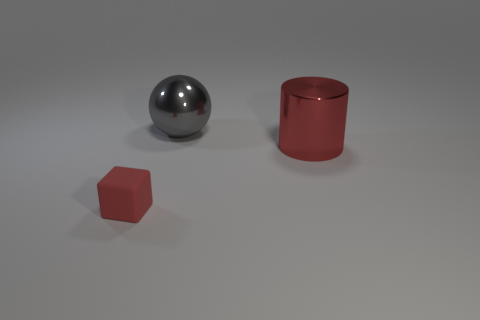Add 3 yellow rubber cubes. How many objects exist? 6 Subtract 0 blue balls. How many objects are left? 3 Subtract all cylinders. How many objects are left? 2 Subtract all brown cylinders. Subtract all blue balls. How many cylinders are left? 1 Subtract all brown balls. Subtract all cylinders. How many objects are left? 2 Add 2 tiny rubber things. How many tiny rubber things are left? 3 Add 2 tiny purple metallic things. How many tiny purple metallic things exist? 2 